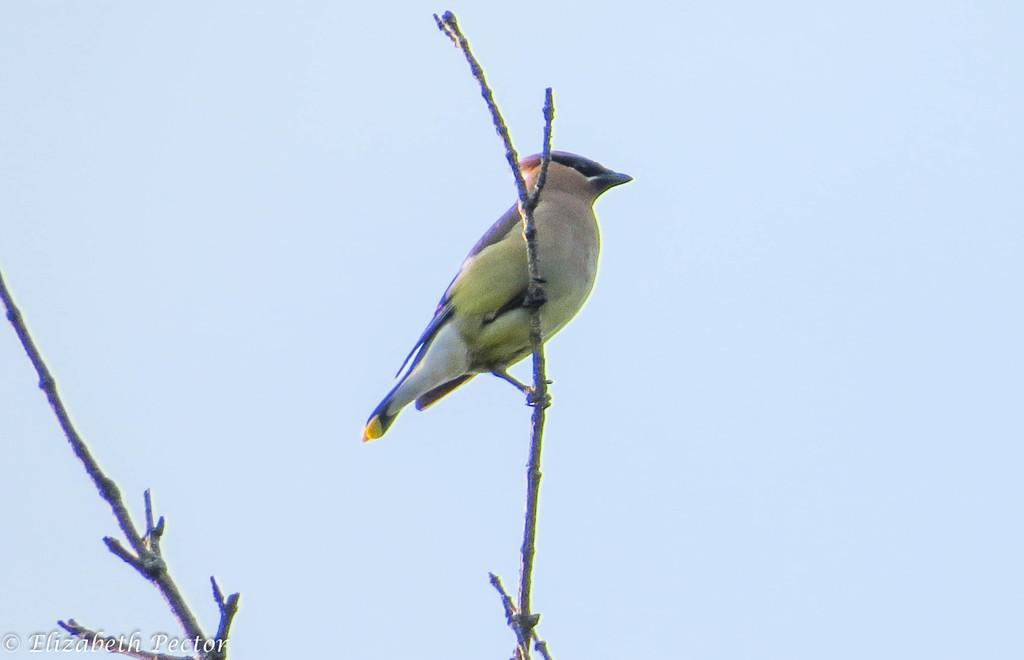What type of animal is in the image? There is a bird in the image. What is the bird doing in the image? The bird is on a stick. What color is the background of the image? The background of the image is blue. Are there any other sticks visible in the image? Yes, there is another stick in the image. What can be found in the bottom left of the image? There is some text in the bottom left of the image. What type of vest is the bird wearing in the image? There is no vest present in the image, and the bird is not wearing any clothing. 